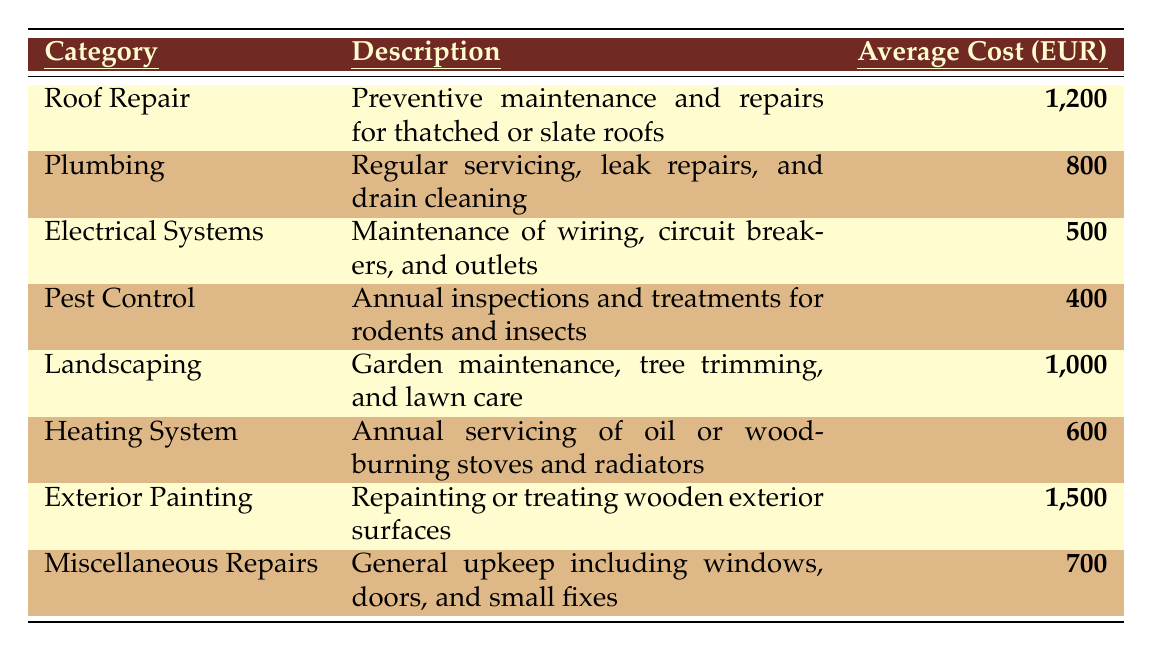What is the average cost for Plumbing maintenance? The average cost for Plumbing maintenance is listed in the table under the "Average Cost (EUR)" column next to the Plumbing category, which shows 800 EUR.
Answer: 800 EUR What is the total cost for Roof Repair and Landscaping combined? The average cost for Roof Repair is 1200 EUR and for Landscaping is 1000 EUR. Adding these together (1200 + 1000) gives a total of 2200 EUR.
Answer: 2200 EUR Is the cost for Pest Control higher than for Electrical Systems? The cost for Pest Control is 400 EUR and for Electrical Systems is 500 EUR. Since 400 is less than 500, the statement is false.
Answer: No What would be the remaining budget if a homeowner allocated 5000 EUR to maintenance costs and paid for all items in the table? The total of all maintenance costs is calculated as follows: 1200 + 800 + 500 + 400 + 1000 + 600 + 1500 + 700 = 5100 EUR. If the homeowner allocated 5000 EUR, the remaining budget would be 5000 - 5100 = -100 EUR, indicating an over-budget situation.
Answer: -100 EUR Which maintenance category has the highest average cost? By reviewing the "Average Cost (EUR)" column, Exterior Painting has the highest average cost at 1500 EUR, compared to the other categories.
Answer: Exterior Painting What is the average maintenance cost across all categories? To find the average cost, first sum all the average costs: 1200 + 800 + 500 + 400 + 1000 + 600 + 1500 + 700 = 5100 EUR. Then divide by the number of categories, which is 8: 5100 / 8 = 637.5 EUR.
Answer: 637.5 EUR If a homeowner only focuses on Electrical Systems and Heating System, what is their total maintenance cost? The average cost for Electrical Systems is 500 EUR, and for Heating System, it is 600 EUR. Adding these gives 500 + 600 = 1100 EUR.
Answer: 1100 EUR Are there more categories with a cost above 800 EUR than below? The categories above 800 EUR are Roof Repair (1200 EUR), Landscaping (1000 EUR), and Exterior Painting (1500 EUR). The categories below are Plumbing (800 EUR), Electrical Systems (500 EUR), Pest Control (400 EUR), Heating System (600 EUR), and Miscellaneous Repairs (700 EUR). There are 3 above 800 EUR and 5 below, so the statement is false.
Answer: No 